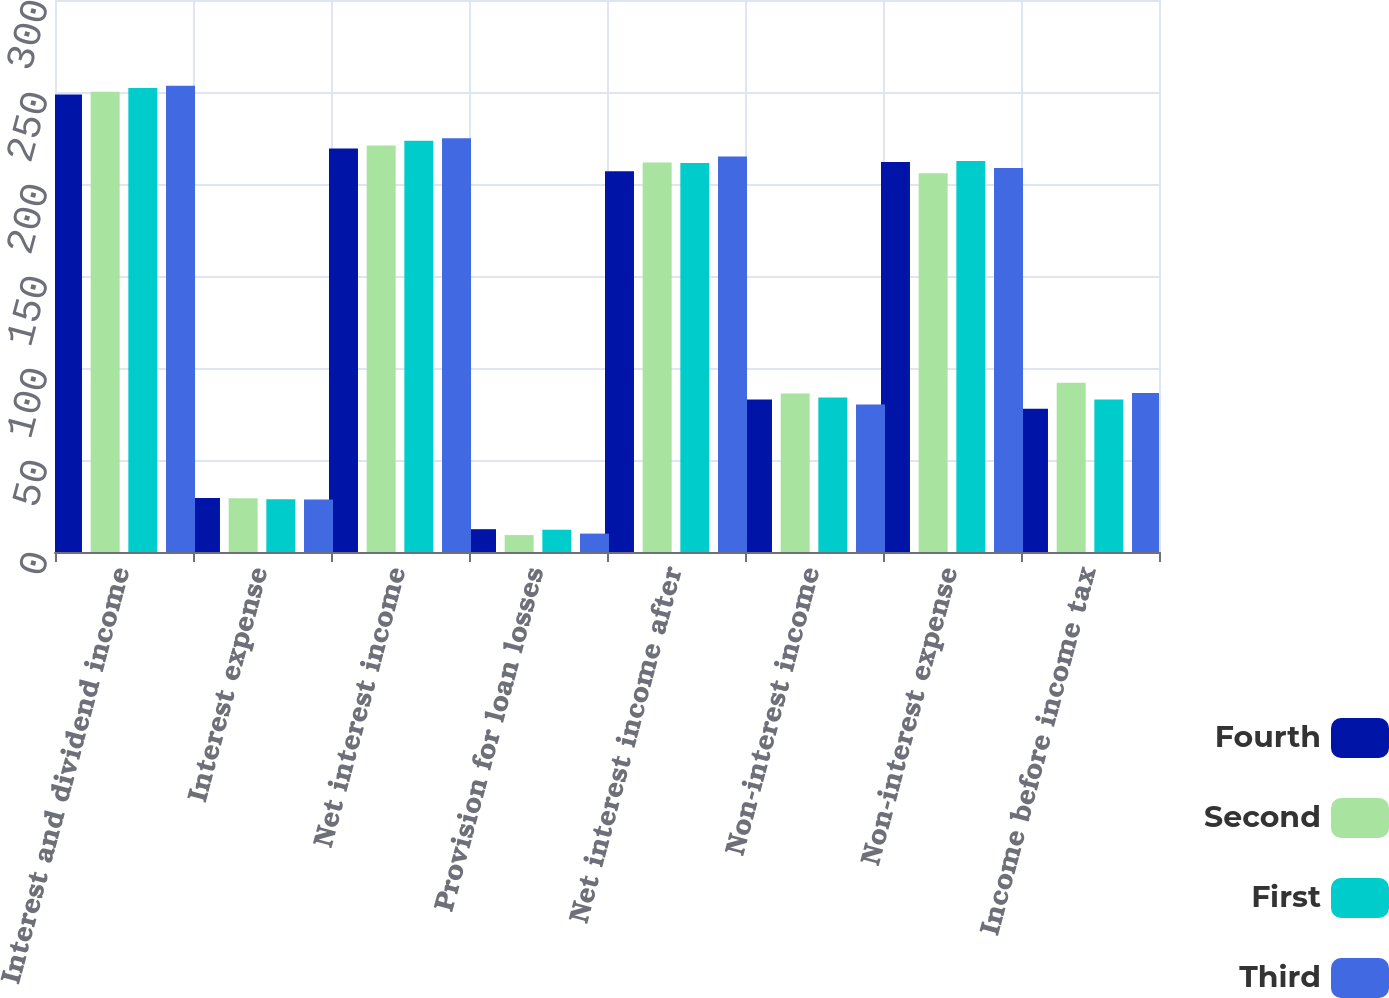<chart> <loc_0><loc_0><loc_500><loc_500><stacked_bar_chart><ecel><fcel>Interest and dividend income<fcel>Interest expense<fcel>Net interest income<fcel>Provision for loan losses<fcel>Net interest income after<fcel>Non-interest income<fcel>Non-interest expense<fcel>Income before income tax<nl><fcel>Fourth<fcel>248.7<fcel>29.4<fcel>219.3<fcel>12.4<fcel>206.9<fcel>82.9<fcel>212<fcel>77.8<nl><fcel>Second<fcel>250.1<fcel>29.2<fcel>220.9<fcel>9.2<fcel>211.7<fcel>86.1<fcel>205.8<fcel>92<nl><fcel>First<fcel>252.2<fcel>28.7<fcel>223.5<fcel>12.1<fcel>211.4<fcel>84<fcel>212.5<fcel>82.9<nl><fcel>Third<fcel>253.4<fcel>28.5<fcel>224.9<fcel>10<fcel>214.9<fcel>80.2<fcel>208.7<fcel>86.4<nl></chart> 